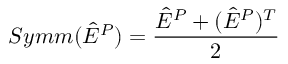<formula> <loc_0><loc_0><loc_500><loc_500>S y m m ( \hat { E } ^ { P } ) = \frac { \hat { E } ^ { P } + ( \hat { E } ^ { P } ) ^ { T } } { 2 }</formula> 